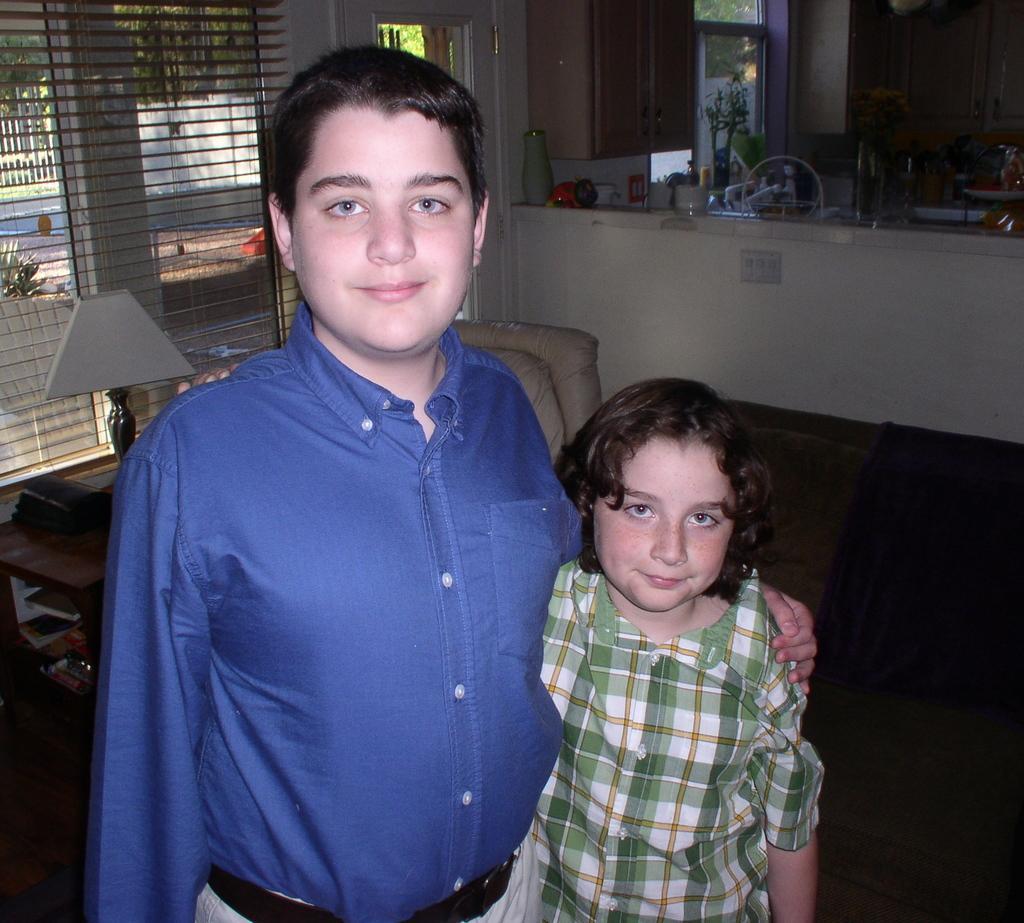Could you give a brief overview of what you see in this image? This picture shows inner view of a room. We see couple of boys standing and we see a table lamp on the table and blinds to the window and we see a kitchen with few bottles and bowls on the counter top and we see a sofa. 